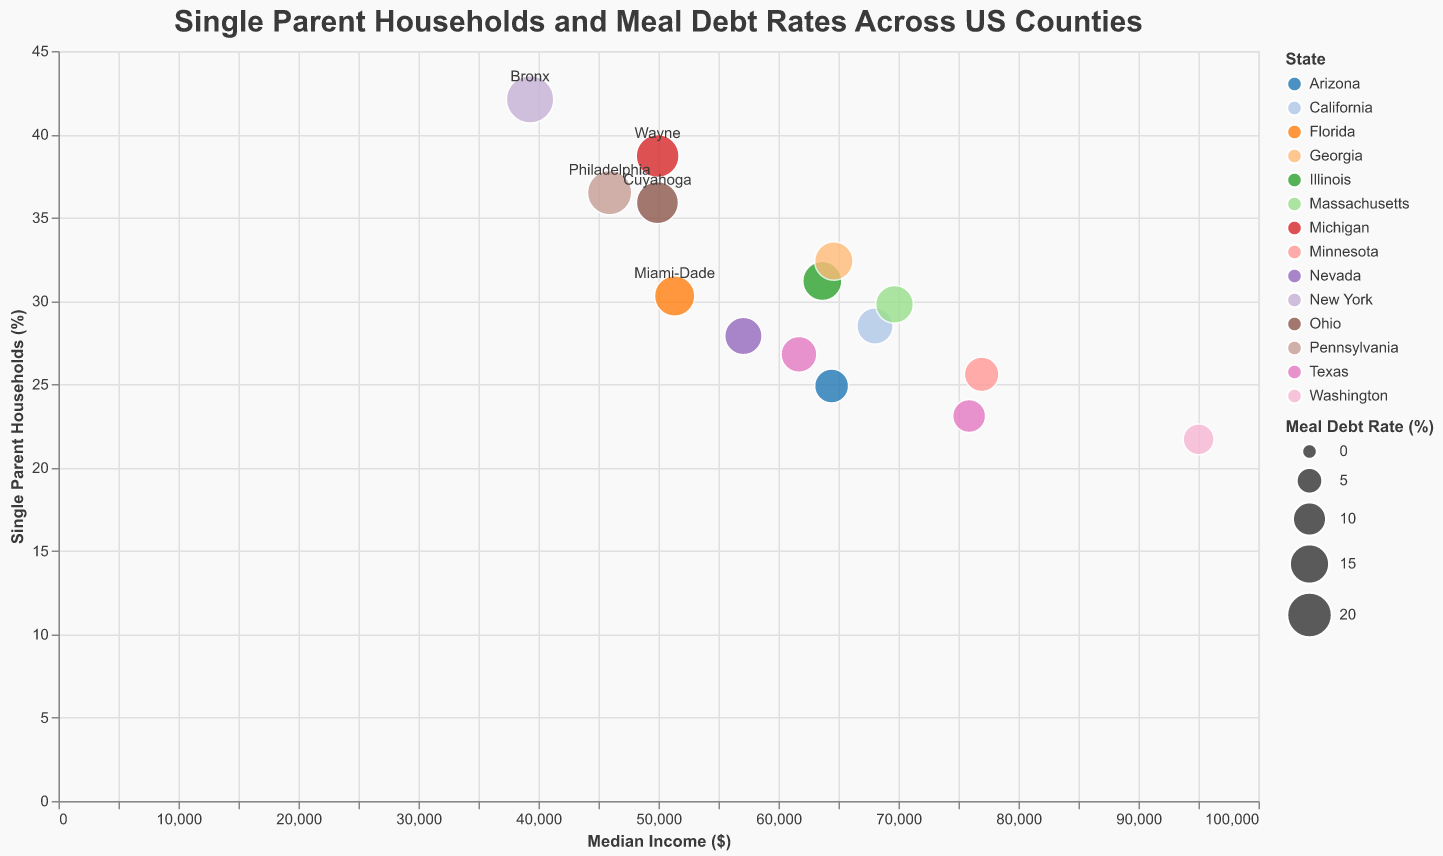What is the average median income of the listed counties? To find the average median income, sum up all the median incomes and divide by the number of counties. It is (68044 + 63653 + 61705 + 64427 + 49928 + 39299 + 45927 + 51347 + 49910 + 95009 + 69669 + 75887 + 76930 + 64615 + 57076) / 15 = 66875
Answer: 66875 Which county has the highest percentage of single-parent households? Look for the highest value in the "Single Parent Households (%)" column. The highest value is 42.1% in Bronx, New York
Answer: Bronx, New York What is the median meal debt rate among the listed counties? To find the median meal debt rate, list all the rates in ascending order and find the middle value. The sorted list is (8.2, 9.7, 10.5, 10.9, 11.9, 12.3, 13.2, 13.5, 14.1, 14.7, 15.8, 17.4, 18.2, 19.6, 22.8). The middle value is 13.2
Answer: 13.2% How many counties have a meal debt rate greater than 15%? Count the number of counties where the "Meal Debt Rate (%)" is greater than 15%. The relevant values are (18.2, 22.8, 19.6, 15.8, 17.4), so there are 5 counties
Answer: 5 counties Which county in Texas has the lowest median income? Locate the counties in Texas (Harris and Travis) and compare their median incomes (Harris: 61705, Travis: 75887). Harris County has the lower median income
Answer: Harris, Texas Is there a county with more than 30% single-parent households and meal debt rate under 15%? Identify counties with "Single Parent Households (%)" > 30% and "Meal Debt Rate (%)" < 15%. Only Cook, Illinois (31.2%, 14.7%) fits the criteria
Answer: Cook, Illinois What is the difference in single-parent household percentages between the county with the highest and lowest median income? Identify the counties with the highest (King, Washington: 95009, 21.7%) and lowest (Bronx, New York: 39299, 42.1%) median incomes. The difference is 42.1 - 21.7 = 20.4%
Answer: 20.4% Are there any counties where the meal debt rate is higher than the percentage of single-parent households? Compare each county's "Meal Debt Rate (%)" with "Single Parent Households (%)". No county satisfies this condition
Answer: No Which county has the lowest meal debt rate? Look for the lowest value in the "Meal Debt Rate (%)" column. The lowest value is 8.2% in King, Washington
Answer: King, Washington 